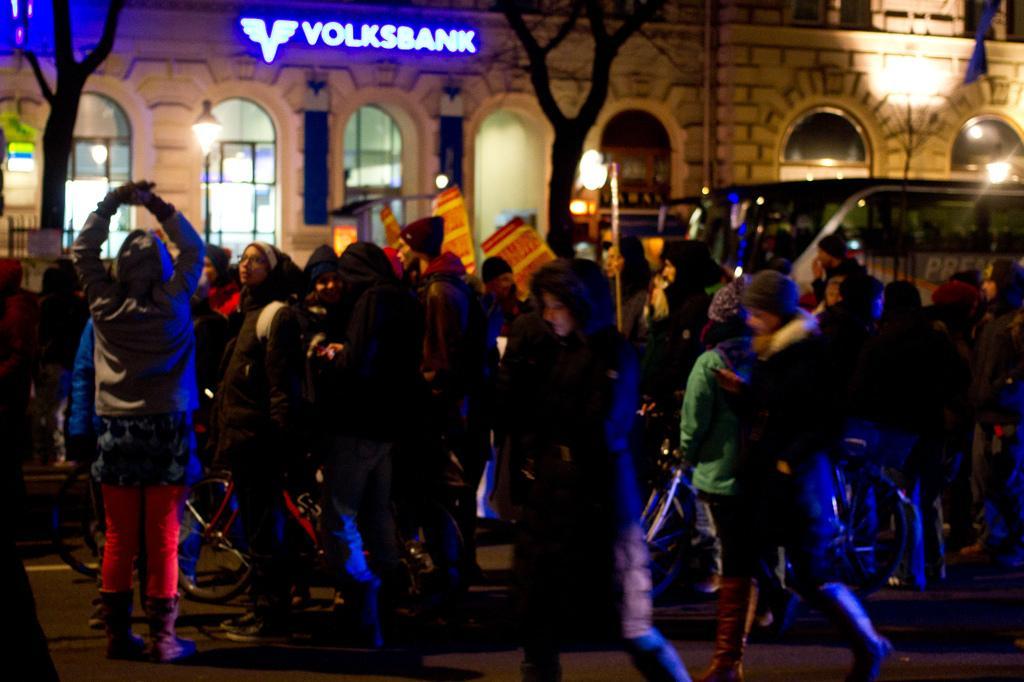Can you describe this image briefly? In this image in the middle there is a woman, she wears a jacket, trouser, she is walking. In the middle there are many people, lights, building, text, vehicle, streetlights, trees, windows, wall. At the bottom there is a road. 